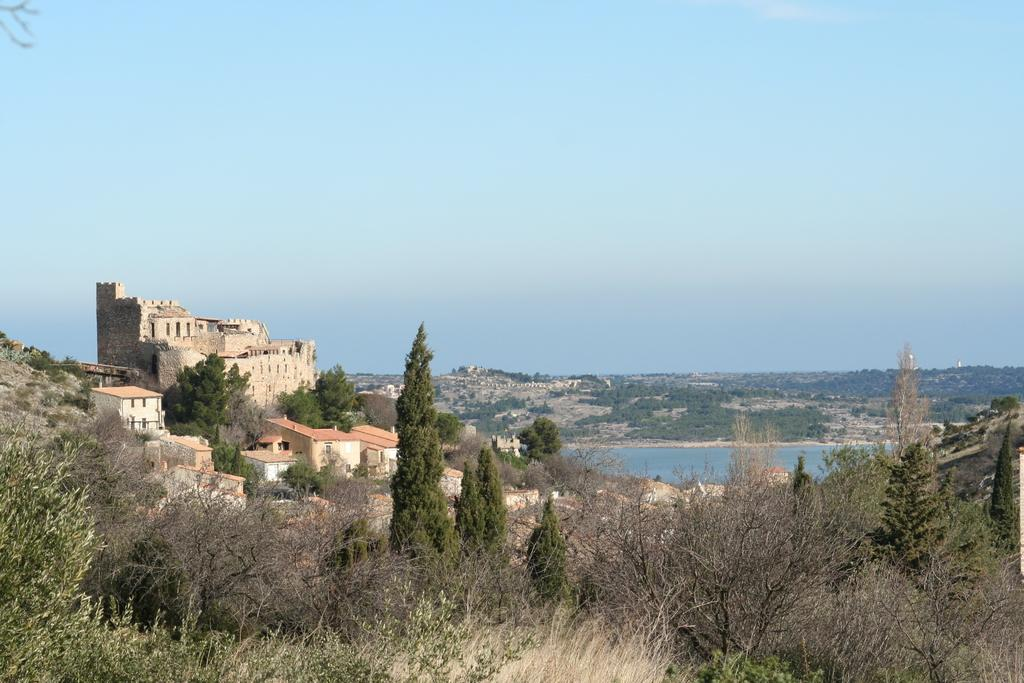What type of structures can be seen in the image? There are buildings in the image. What natural elements are present in the image? There are trees, a mountain, and plants in the image. What is visible at the top of the image? The sky is visible at the top of the image. What is visible at the bottom of the image? There is water visible at the bottom of the image. Can you see a woman wearing a hat near the water in the image? There is no woman wearing a hat present in the image. What type of sea creatures can be seen swimming in the water at the bottom of the image? There is: There are no sea creatures visible in the image, as it only shows water at the bottom. 